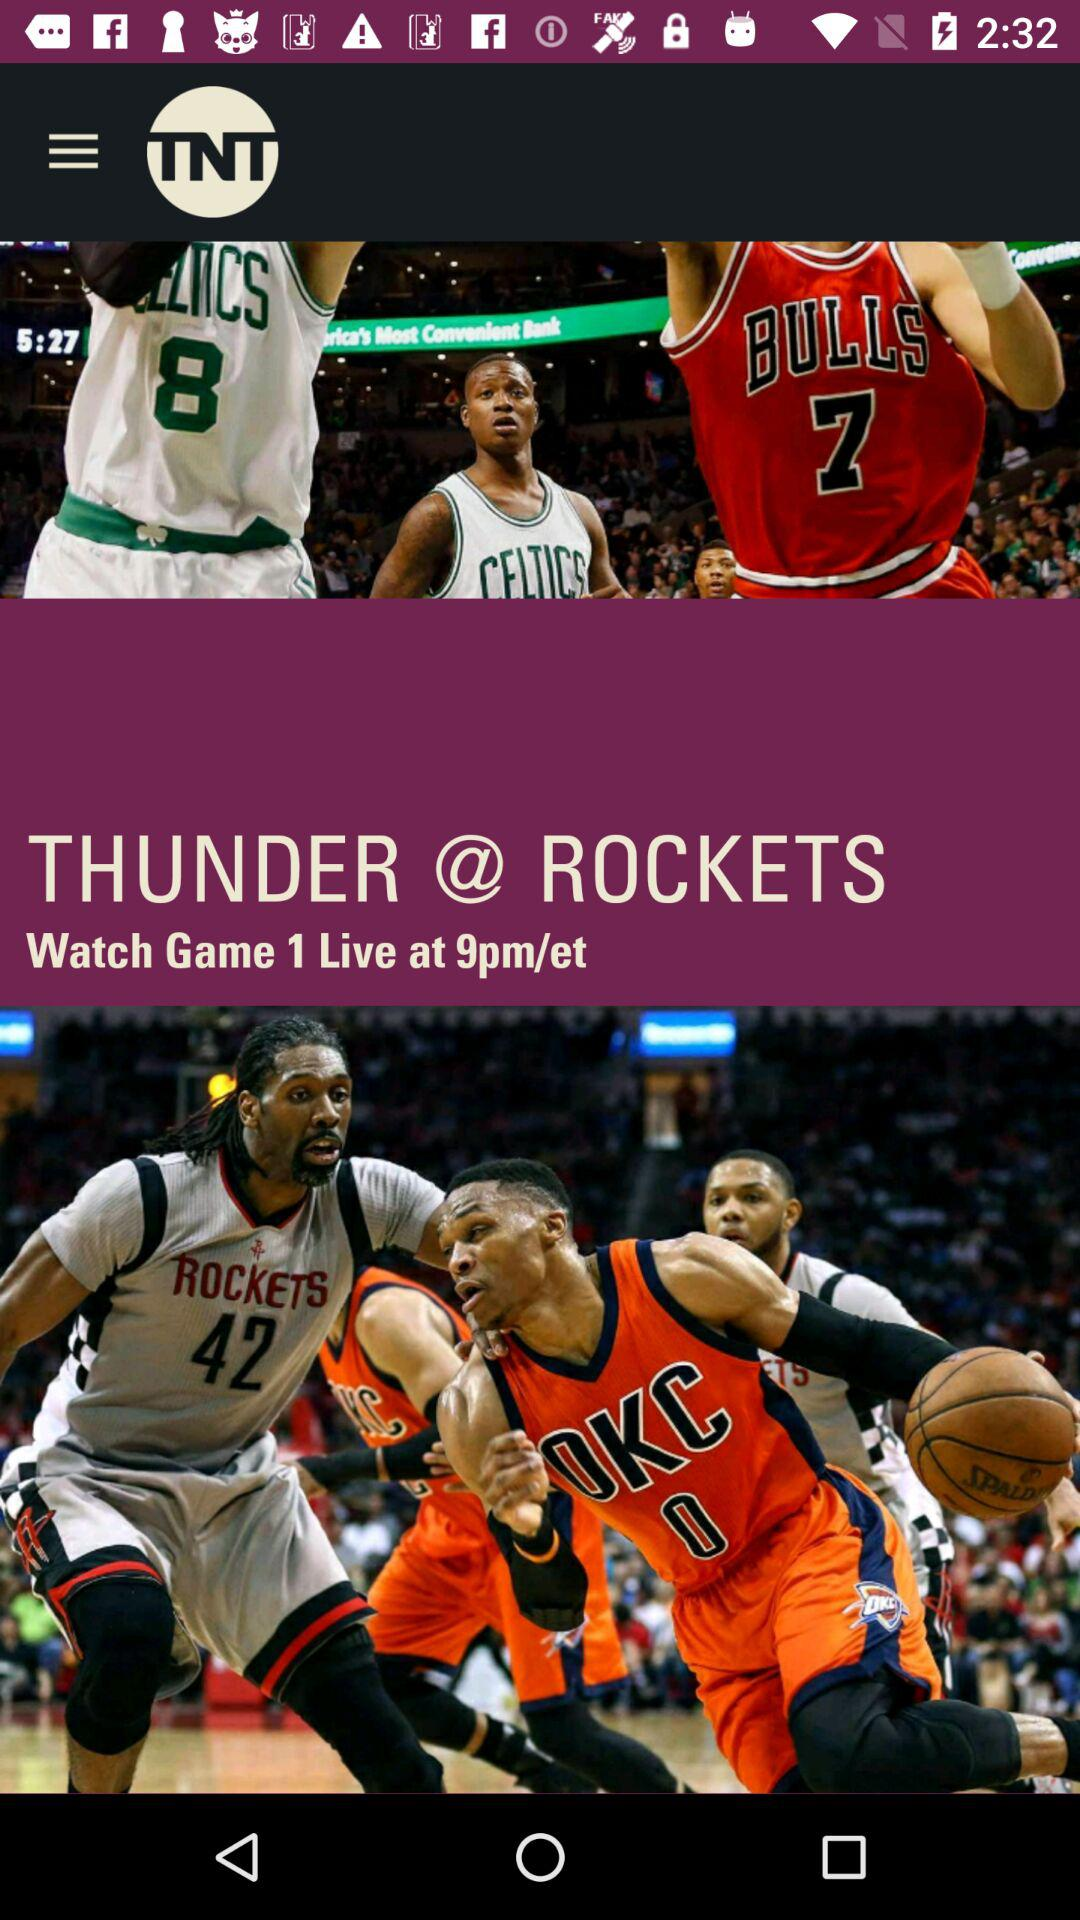What is the time to watch a live game? The time is 9pm/et. 